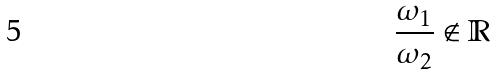Convert formula to latex. <formula><loc_0><loc_0><loc_500><loc_500>\frac { \omega _ { 1 } } { \omega _ { 2 } } \notin \mathbb { R }</formula> 